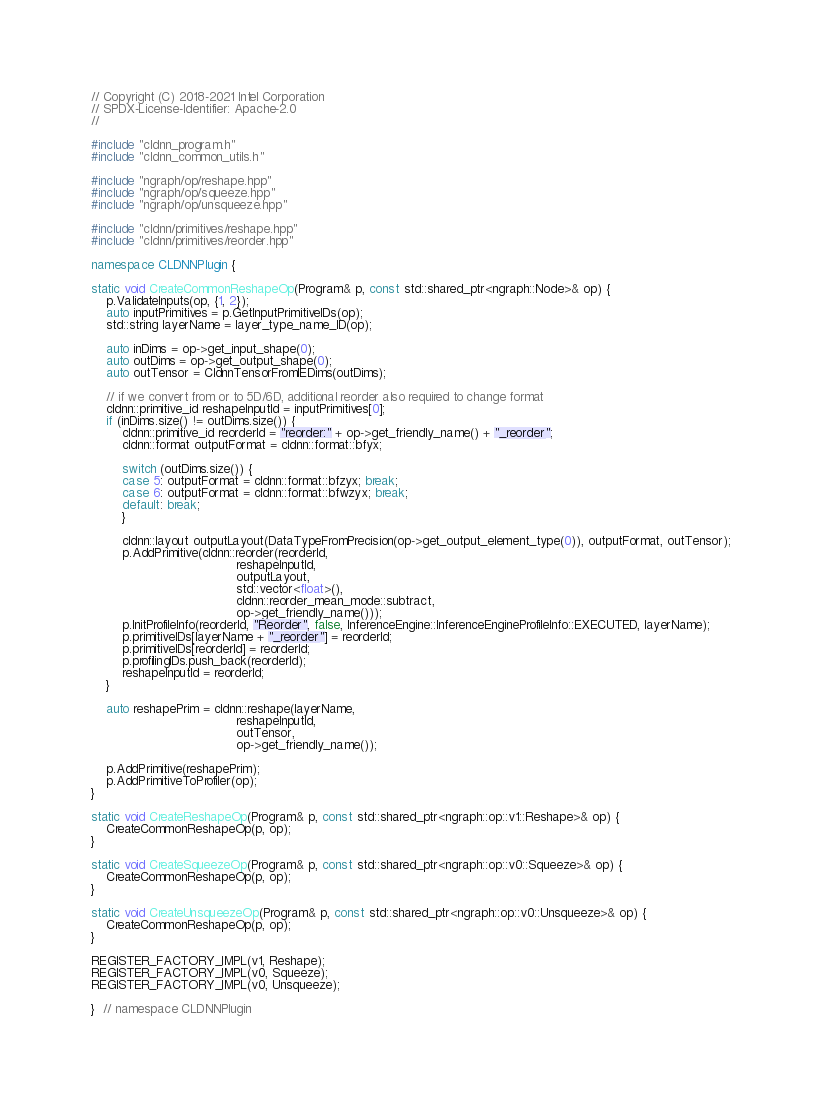<code> <loc_0><loc_0><loc_500><loc_500><_C++_>// Copyright (C) 2018-2021 Intel Corporation
// SPDX-License-Identifier: Apache-2.0
//

#include "cldnn_program.h"
#include "cldnn_common_utils.h"

#include "ngraph/op/reshape.hpp"
#include "ngraph/op/squeeze.hpp"
#include "ngraph/op/unsqueeze.hpp"

#include "cldnn/primitives/reshape.hpp"
#include "cldnn/primitives/reorder.hpp"

namespace CLDNNPlugin {

static void CreateCommonReshapeOp(Program& p, const std::shared_ptr<ngraph::Node>& op) {
    p.ValidateInputs(op, {1, 2});
    auto inputPrimitives = p.GetInputPrimitiveIDs(op);
    std::string layerName = layer_type_name_ID(op);

    auto inDims = op->get_input_shape(0);
    auto outDims = op->get_output_shape(0);
    auto outTensor = CldnnTensorFromIEDims(outDims);

    // if we convert from or to 5D/6D, additional reorder also required to change format
    cldnn::primitive_id reshapeInputId = inputPrimitives[0];
    if (inDims.size() != outDims.size()) {
        cldnn::primitive_id reorderId = "reorder:" + op->get_friendly_name() + "_reorder";
        cldnn::format outputFormat = cldnn::format::bfyx;

        switch (outDims.size()) {
        case 5: outputFormat = cldnn::format::bfzyx; break;
        case 6: outputFormat = cldnn::format::bfwzyx; break;
        default: break;
        }

        cldnn::layout outputLayout(DataTypeFromPrecision(op->get_output_element_type(0)), outputFormat, outTensor);
        p.AddPrimitive(cldnn::reorder(reorderId,
                                      reshapeInputId,
                                      outputLayout,
                                      std::vector<float>(),
                                      cldnn::reorder_mean_mode::subtract,
                                      op->get_friendly_name()));
        p.InitProfileInfo(reorderId, "Reorder", false, InferenceEngine::InferenceEngineProfileInfo::EXECUTED, layerName);
        p.primitiveIDs[layerName + "_reorder"] = reorderId;
        p.primitiveIDs[reorderId] = reorderId;
        p.profilingIDs.push_back(reorderId);
        reshapeInputId = reorderId;
    }

    auto reshapePrim = cldnn::reshape(layerName,
                                      reshapeInputId,
                                      outTensor,
                                      op->get_friendly_name());

    p.AddPrimitive(reshapePrim);
    p.AddPrimitiveToProfiler(op);
}

static void CreateReshapeOp(Program& p, const std::shared_ptr<ngraph::op::v1::Reshape>& op) {
    CreateCommonReshapeOp(p, op);
}

static void CreateSqueezeOp(Program& p, const std::shared_ptr<ngraph::op::v0::Squeeze>& op) {
    CreateCommonReshapeOp(p, op);
}

static void CreateUnsqueezeOp(Program& p, const std::shared_ptr<ngraph::op::v0::Unsqueeze>& op) {
    CreateCommonReshapeOp(p, op);
}

REGISTER_FACTORY_IMPL(v1, Reshape);
REGISTER_FACTORY_IMPL(v0, Squeeze);
REGISTER_FACTORY_IMPL(v0, Unsqueeze);

}  // namespace CLDNNPlugin
</code> 